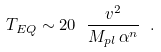<formula> <loc_0><loc_0><loc_500><loc_500>T _ { E Q } \sim 2 0 \ \frac { v ^ { 2 } } { M _ { p l } \, \alpha ^ { n } } \ .</formula> 